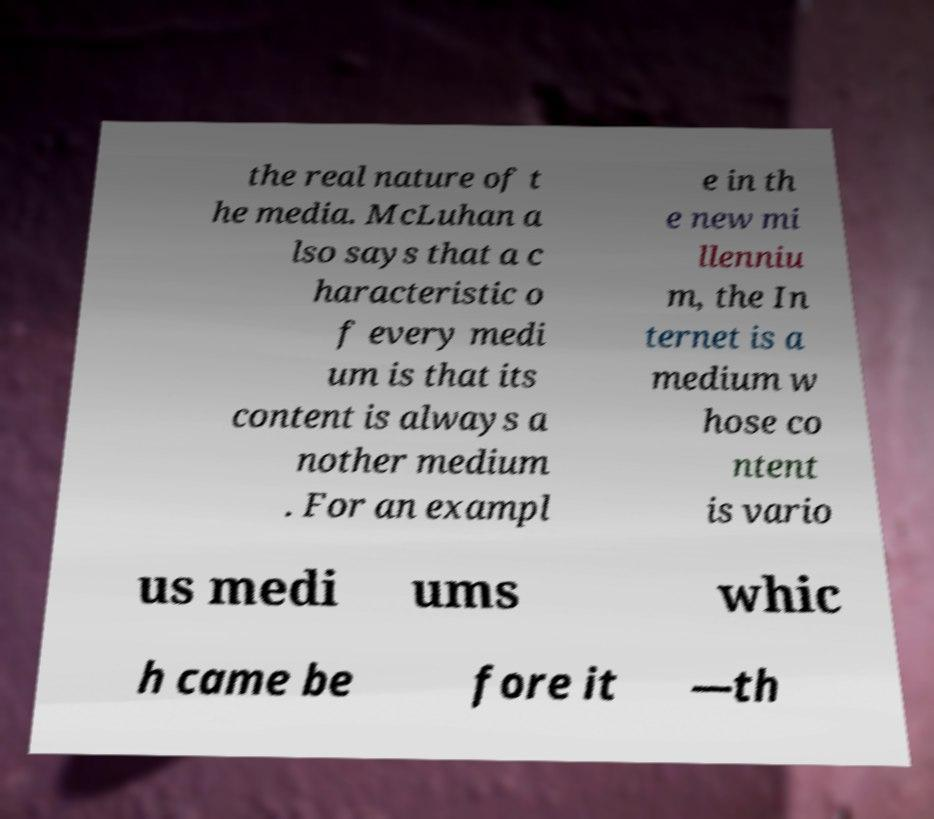Please identify and transcribe the text found in this image. the real nature of t he media. McLuhan a lso says that a c haracteristic o f every medi um is that its content is always a nother medium . For an exampl e in th e new mi llenniu m, the In ternet is a medium w hose co ntent is vario us medi ums whic h came be fore it —th 